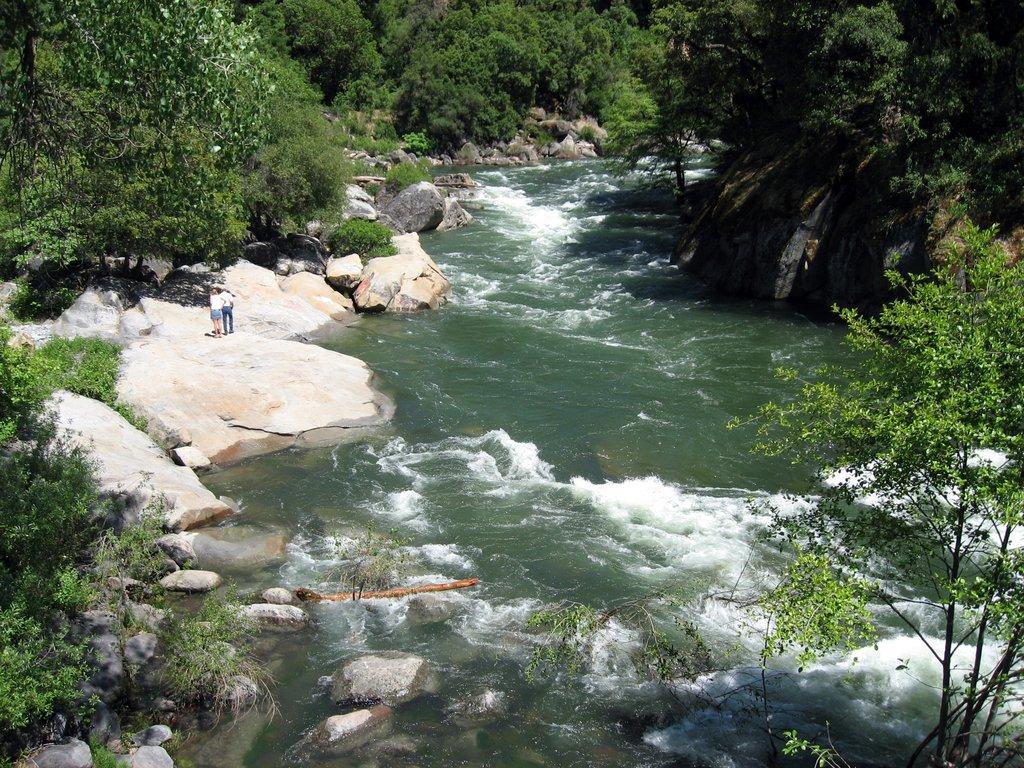Please provide a concise description of this image. In the image on left side we can see two persons are standing on stone and we can also see trees from right to left, in middle there is a water as it is a lake and background we can also see some stones. 